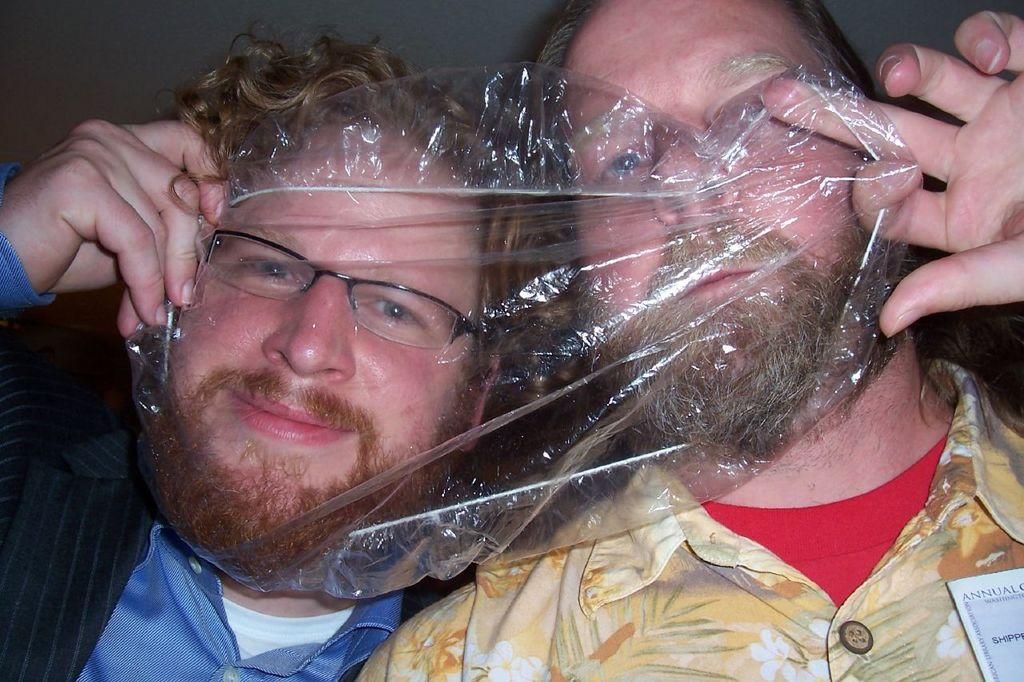How many people are in the foreground of the image? There are two men in the foreground of the image. What are the men doing in the image? The men are covering their faces with a plastic sheet. What type of fang can be seen in the image? There is no fang present in the image; it features two men covering their faces with a plastic sheet. How are the men measuring the distance between them in the image? The men are not measuring the distance between them in the image; they are covering their faces with a plastic sheet. 